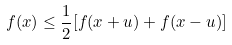Convert formula to latex. <formula><loc_0><loc_0><loc_500><loc_500>f ( x ) \leq \frac { 1 } { 2 } [ f ( x + u ) + f ( x - u ) ]</formula> 